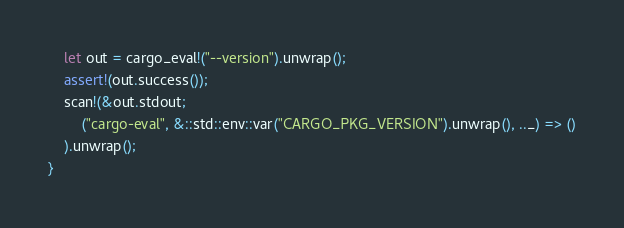Convert code to text. <code><loc_0><loc_0><loc_500><loc_500><_Rust_>    let out = cargo_eval!("--version").unwrap();
    assert!(out.success());
    scan!(&out.stdout;
        ("cargo-eval", &::std::env::var("CARGO_PKG_VERSION").unwrap(), .._) => ()
    ).unwrap();
}
</code> 